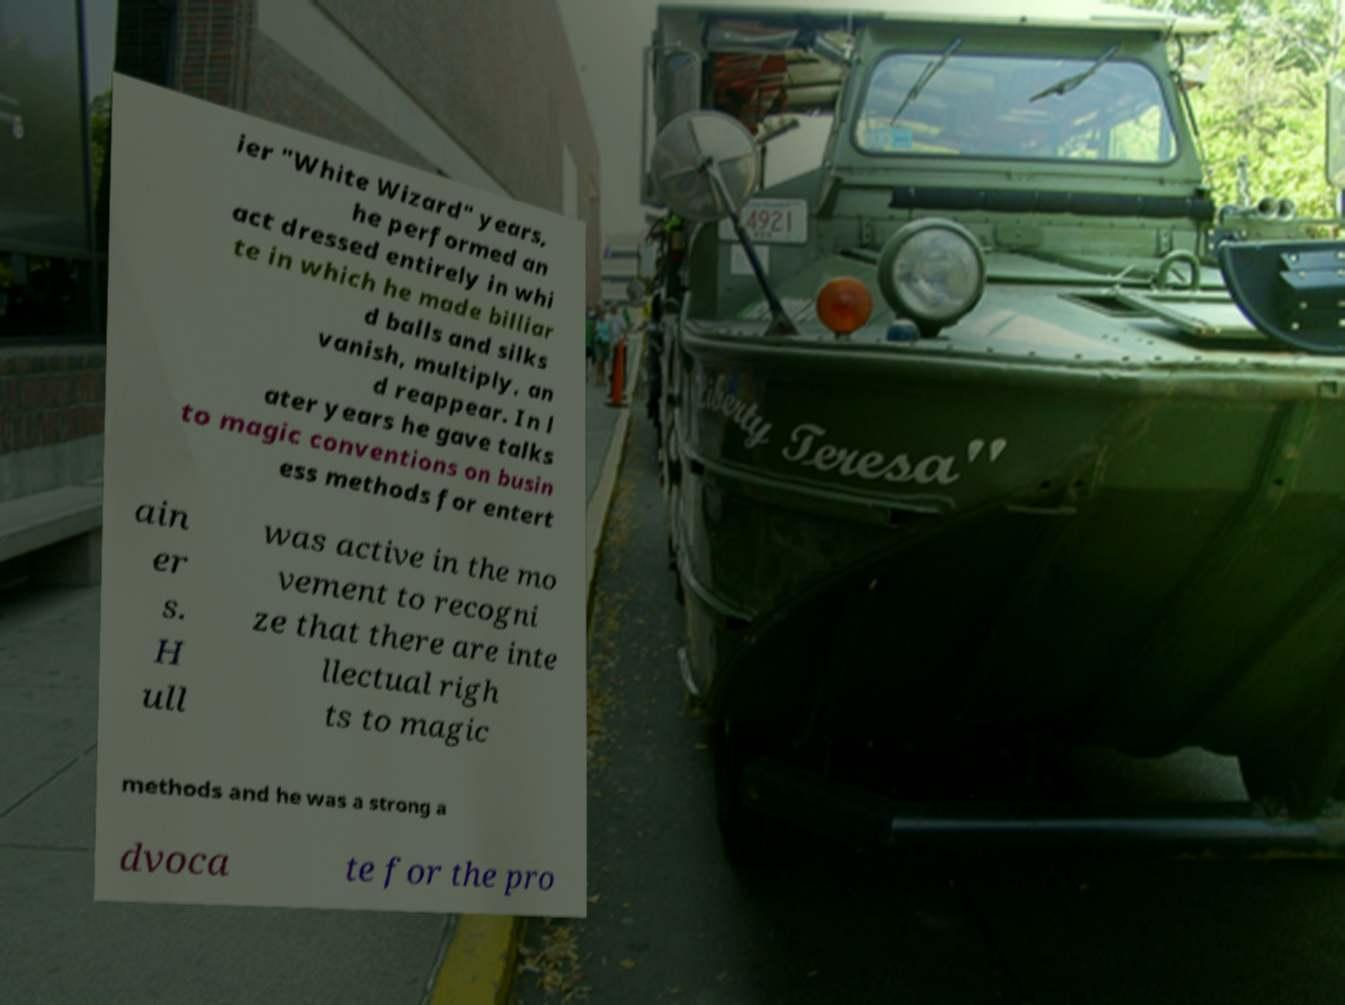Please identify and transcribe the text found in this image. ier "White Wizard" years, he performed an act dressed entirely in whi te in which he made billiar d balls and silks vanish, multiply, an d reappear. In l ater years he gave talks to magic conventions on busin ess methods for entert ain er s. H ull was active in the mo vement to recogni ze that there are inte llectual righ ts to magic methods and he was a strong a dvoca te for the pro 